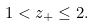<formula> <loc_0><loc_0><loc_500><loc_500>1 < z _ { + } \leq 2 .</formula> 